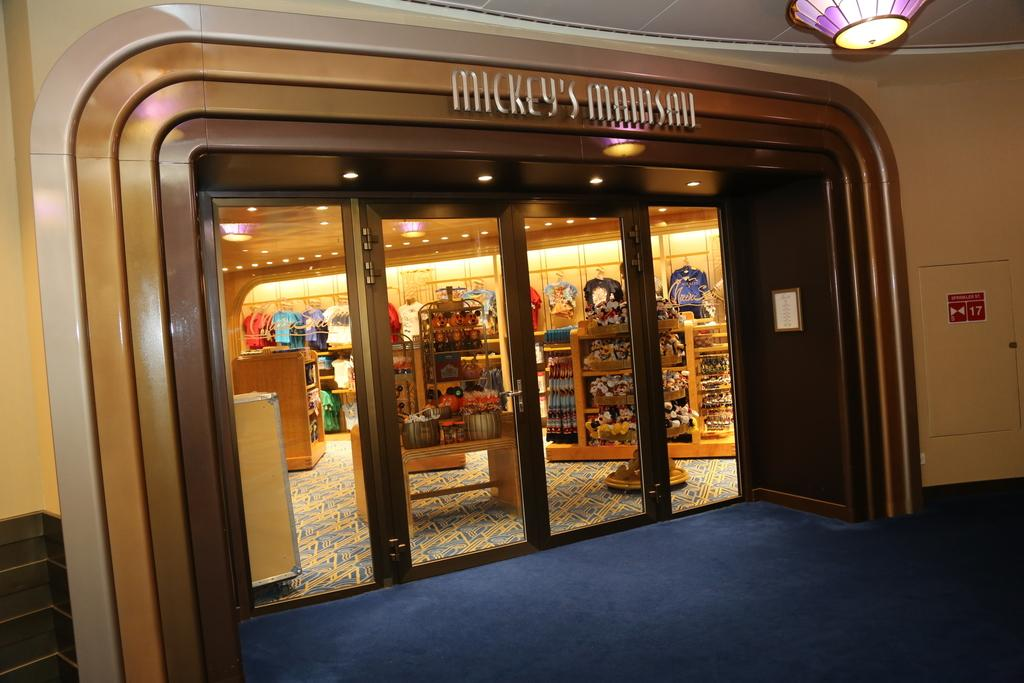<image>
Offer a succinct explanation of the picture presented. Looking into the store front of Mickeys Main Sail 